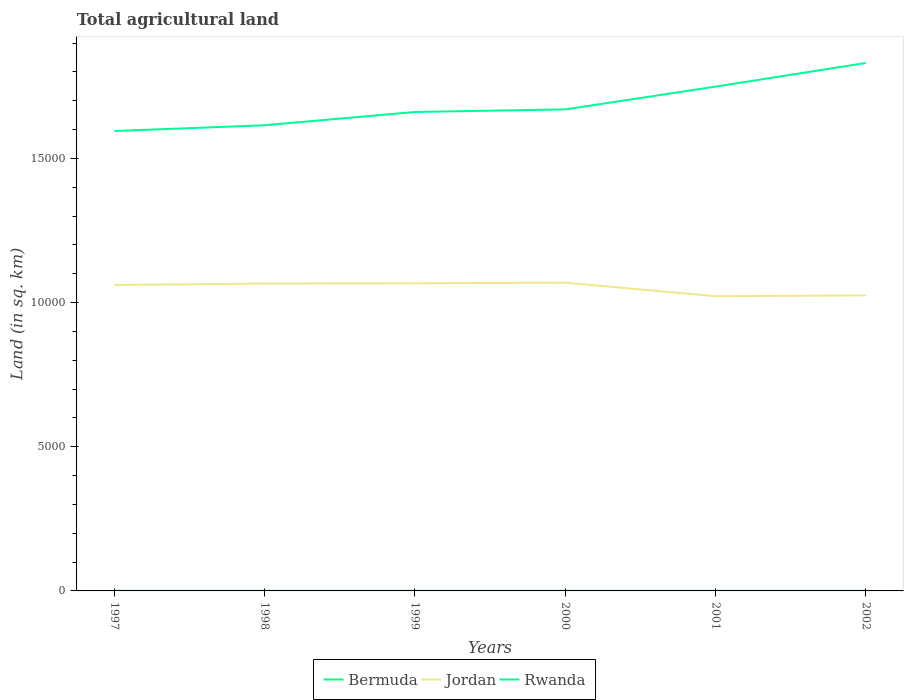How many different coloured lines are there?
Give a very brief answer. 3. Does the line corresponding to Jordan intersect with the line corresponding to Bermuda?
Ensure brevity in your answer.  No. Across all years, what is the maximum total agricultural land in Bermuda?
Give a very brief answer. 4. What is the difference between the highest and the second highest total agricultural land in Rwanda?
Offer a terse response. 2360. How many years are there in the graph?
Your answer should be very brief. 6. What is the difference between two consecutive major ticks on the Y-axis?
Keep it short and to the point. 5000. Does the graph contain grids?
Offer a very short reply. No. Where does the legend appear in the graph?
Your answer should be very brief. Bottom center. How are the legend labels stacked?
Offer a terse response. Horizontal. What is the title of the graph?
Provide a short and direct response. Total agricultural land. What is the label or title of the X-axis?
Offer a terse response. Years. What is the label or title of the Y-axis?
Ensure brevity in your answer.  Land (in sq. km). What is the Land (in sq. km) of Bermuda in 1997?
Keep it short and to the point. 4. What is the Land (in sq. km) of Jordan in 1997?
Your answer should be very brief. 1.06e+04. What is the Land (in sq. km) in Rwanda in 1997?
Make the answer very short. 1.60e+04. What is the Land (in sq. km) of Jordan in 1998?
Offer a terse response. 1.07e+04. What is the Land (in sq. km) in Rwanda in 1998?
Ensure brevity in your answer.  1.62e+04. What is the Land (in sq. km) of Jordan in 1999?
Your response must be concise. 1.07e+04. What is the Land (in sq. km) of Rwanda in 1999?
Your answer should be very brief. 1.66e+04. What is the Land (in sq. km) in Bermuda in 2000?
Provide a succinct answer. 4. What is the Land (in sq. km) of Jordan in 2000?
Keep it short and to the point. 1.07e+04. What is the Land (in sq. km) of Rwanda in 2000?
Your answer should be very brief. 1.67e+04. What is the Land (in sq. km) of Jordan in 2001?
Offer a terse response. 1.02e+04. What is the Land (in sq. km) in Rwanda in 2001?
Your response must be concise. 1.75e+04. What is the Land (in sq. km) of Jordan in 2002?
Keep it short and to the point. 1.02e+04. What is the Land (in sq. km) in Rwanda in 2002?
Keep it short and to the point. 1.83e+04. Across all years, what is the maximum Land (in sq. km) in Jordan?
Provide a succinct answer. 1.07e+04. Across all years, what is the maximum Land (in sq. km) of Rwanda?
Keep it short and to the point. 1.83e+04. Across all years, what is the minimum Land (in sq. km) of Jordan?
Offer a terse response. 1.02e+04. Across all years, what is the minimum Land (in sq. km) in Rwanda?
Your answer should be very brief. 1.60e+04. What is the total Land (in sq. km) of Bermuda in the graph?
Your response must be concise. 24. What is the total Land (in sq. km) of Jordan in the graph?
Give a very brief answer. 6.31e+04. What is the total Land (in sq. km) in Rwanda in the graph?
Your answer should be very brief. 1.01e+05. What is the difference between the Land (in sq. km) of Bermuda in 1997 and that in 1998?
Provide a short and direct response. 0. What is the difference between the Land (in sq. km) in Jordan in 1997 and that in 1998?
Make the answer very short. -50. What is the difference between the Land (in sq. km) of Rwanda in 1997 and that in 1998?
Offer a very short reply. -200. What is the difference between the Land (in sq. km) of Bermuda in 1997 and that in 1999?
Give a very brief answer. 0. What is the difference between the Land (in sq. km) in Jordan in 1997 and that in 1999?
Your answer should be very brief. -60. What is the difference between the Land (in sq. km) in Rwanda in 1997 and that in 1999?
Your answer should be very brief. -660. What is the difference between the Land (in sq. km) in Bermuda in 1997 and that in 2000?
Give a very brief answer. 0. What is the difference between the Land (in sq. km) in Jordan in 1997 and that in 2000?
Keep it short and to the point. -80. What is the difference between the Land (in sq. km) in Rwanda in 1997 and that in 2000?
Keep it short and to the point. -750. What is the difference between the Land (in sq. km) of Bermuda in 1997 and that in 2001?
Ensure brevity in your answer.  0. What is the difference between the Land (in sq. km) of Jordan in 1997 and that in 2001?
Your answer should be compact. 390. What is the difference between the Land (in sq. km) in Rwanda in 1997 and that in 2001?
Make the answer very short. -1540. What is the difference between the Land (in sq. km) in Jordan in 1997 and that in 2002?
Make the answer very short. 360. What is the difference between the Land (in sq. km) in Rwanda in 1997 and that in 2002?
Give a very brief answer. -2360. What is the difference between the Land (in sq. km) of Bermuda in 1998 and that in 1999?
Keep it short and to the point. 0. What is the difference between the Land (in sq. km) in Rwanda in 1998 and that in 1999?
Keep it short and to the point. -460. What is the difference between the Land (in sq. km) of Jordan in 1998 and that in 2000?
Make the answer very short. -30. What is the difference between the Land (in sq. km) of Rwanda in 1998 and that in 2000?
Your response must be concise. -550. What is the difference between the Land (in sq. km) in Bermuda in 1998 and that in 2001?
Offer a terse response. 0. What is the difference between the Land (in sq. km) in Jordan in 1998 and that in 2001?
Your answer should be compact. 440. What is the difference between the Land (in sq. km) in Rwanda in 1998 and that in 2001?
Offer a very short reply. -1340. What is the difference between the Land (in sq. km) in Jordan in 1998 and that in 2002?
Keep it short and to the point. 410. What is the difference between the Land (in sq. km) of Rwanda in 1998 and that in 2002?
Ensure brevity in your answer.  -2160. What is the difference between the Land (in sq. km) in Jordan in 1999 and that in 2000?
Provide a short and direct response. -20. What is the difference between the Land (in sq. km) of Rwanda in 1999 and that in 2000?
Keep it short and to the point. -90. What is the difference between the Land (in sq. km) in Bermuda in 1999 and that in 2001?
Make the answer very short. 0. What is the difference between the Land (in sq. km) in Jordan in 1999 and that in 2001?
Your answer should be very brief. 450. What is the difference between the Land (in sq. km) of Rwanda in 1999 and that in 2001?
Provide a succinct answer. -880. What is the difference between the Land (in sq. km) in Bermuda in 1999 and that in 2002?
Offer a very short reply. 0. What is the difference between the Land (in sq. km) of Jordan in 1999 and that in 2002?
Your answer should be compact. 420. What is the difference between the Land (in sq. km) in Rwanda in 1999 and that in 2002?
Provide a short and direct response. -1700. What is the difference between the Land (in sq. km) of Jordan in 2000 and that in 2001?
Provide a short and direct response. 470. What is the difference between the Land (in sq. km) of Rwanda in 2000 and that in 2001?
Provide a succinct answer. -790. What is the difference between the Land (in sq. km) in Bermuda in 2000 and that in 2002?
Provide a short and direct response. 0. What is the difference between the Land (in sq. km) in Jordan in 2000 and that in 2002?
Make the answer very short. 440. What is the difference between the Land (in sq. km) in Rwanda in 2000 and that in 2002?
Your answer should be very brief. -1610. What is the difference between the Land (in sq. km) of Bermuda in 2001 and that in 2002?
Give a very brief answer. 0. What is the difference between the Land (in sq. km) in Rwanda in 2001 and that in 2002?
Keep it short and to the point. -820. What is the difference between the Land (in sq. km) in Bermuda in 1997 and the Land (in sq. km) in Jordan in 1998?
Your answer should be compact. -1.07e+04. What is the difference between the Land (in sq. km) in Bermuda in 1997 and the Land (in sq. km) in Rwanda in 1998?
Ensure brevity in your answer.  -1.61e+04. What is the difference between the Land (in sq. km) of Jordan in 1997 and the Land (in sq. km) of Rwanda in 1998?
Ensure brevity in your answer.  -5540. What is the difference between the Land (in sq. km) in Bermuda in 1997 and the Land (in sq. km) in Jordan in 1999?
Give a very brief answer. -1.07e+04. What is the difference between the Land (in sq. km) of Bermuda in 1997 and the Land (in sq. km) of Rwanda in 1999?
Ensure brevity in your answer.  -1.66e+04. What is the difference between the Land (in sq. km) of Jordan in 1997 and the Land (in sq. km) of Rwanda in 1999?
Ensure brevity in your answer.  -6000. What is the difference between the Land (in sq. km) in Bermuda in 1997 and the Land (in sq. km) in Jordan in 2000?
Your answer should be very brief. -1.07e+04. What is the difference between the Land (in sq. km) in Bermuda in 1997 and the Land (in sq. km) in Rwanda in 2000?
Make the answer very short. -1.67e+04. What is the difference between the Land (in sq. km) of Jordan in 1997 and the Land (in sq. km) of Rwanda in 2000?
Offer a very short reply. -6090. What is the difference between the Land (in sq. km) of Bermuda in 1997 and the Land (in sq. km) of Jordan in 2001?
Your answer should be very brief. -1.02e+04. What is the difference between the Land (in sq. km) of Bermuda in 1997 and the Land (in sq. km) of Rwanda in 2001?
Your answer should be very brief. -1.75e+04. What is the difference between the Land (in sq. km) in Jordan in 1997 and the Land (in sq. km) in Rwanda in 2001?
Provide a short and direct response. -6880. What is the difference between the Land (in sq. km) in Bermuda in 1997 and the Land (in sq. km) in Jordan in 2002?
Your response must be concise. -1.02e+04. What is the difference between the Land (in sq. km) in Bermuda in 1997 and the Land (in sq. km) in Rwanda in 2002?
Your answer should be compact. -1.83e+04. What is the difference between the Land (in sq. km) of Jordan in 1997 and the Land (in sq. km) of Rwanda in 2002?
Ensure brevity in your answer.  -7700. What is the difference between the Land (in sq. km) of Bermuda in 1998 and the Land (in sq. km) of Jordan in 1999?
Give a very brief answer. -1.07e+04. What is the difference between the Land (in sq. km) in Bermuda in 1998 and the Land (in sq. km) in Rwanda in 1999?
Offer a very short reply. -1.66e+04. What is the difference between the Land (in sq. km) of Jordan in 1998 and the Land (in sq. km) of Rwanda in 1999?
Provide a short and direct response. -5950. What is the difference between the Land (in sq. km) of Bermuda in 1998 and the Land (in sq. km) of Jordan in 2000?
Give a very brief answer. -1.07e+04. What is the difference between the Land (in sq. km) of Bermuda in 1998 and the Land (in sq. km) of Rwanda in 2000?
Provide a short and direct response. -1.67e+04. What is the difference between the Land (in sq. km) in Jordan in 1998 and the Land (in sq. km) in Rwanda in 2000?
Offer a very short reply. -6040. What is the difference between the Land (in sq. km) in Bermuda in 1998 and the Land (in sq. km) in Jordan in 2001?
Provide a succinct answer. -1.02e+04. What is the difference between the Land (in sq. km) of Bermuda in 1998 and the Land (in sq. km) of Rwanda in 2001?
Make the answer very short. -1.75e+04. What is the difference between the Land (in sq. km) of Jordan in 1998 and the Land (in sq. km) of Rwanda in 2001?
Provide a short and direct response. -6830. What is the difference between the Land (in sq. km) of Bermuda in 1998 and the Land (in sq. km) of Jordan in 2002?
Keep it short and to the point. -1.02e+04. What is the difference between the Land (in sq. km) of Bermuda in 1998 and the Land (in sq. km) of Rwanda in 2002?
Give a very brief answer. -1.83e+04. What is the difference between the Land (in sq. km) in Jordan in 1998 and the Land (in sq. km) in Rwanda in 2002?
Offer a terse response. -7650. What is the difference between the Land (in sq. km) of Bermuda in 1999 and the Land (in sq. km) of Jordan in 2000?
Give a very brief answer. -1.07e+04. What is the difference between the Land (in sq. km) of Bermuda in 1999 and the Land (in sq. km) of Rwanda in 2000?
Provide a succinct answer. -1.67e+04. What is the difference between the Land (in sq. km) of Jordan in 1999 and the Land (in sq. km) of Rwanda in 2000?
Offer a very short reply. -6030. What is the difference between the Land (in sq. km) in Bermuda in 1999 and the Land (in sq. km) in Jordan in 2001?
Your answer should be compact. -1.02e+04. What is the difference between the Land (in sq. km) of Bermuda in 1999 and the Land (in sq. km) of Rwanda in 2001?
Your answer should be very brief. -1.75e+04. What is the difference between the Land (in sq. km) of Jordan in 1999 and the Land (in sq. km) of Rwanda in 2001?
Provide a succinct answer. -6820. What is the difference between the Land (in sq. km) of Bermuda in 1999 and the Land (in sq. km) of Jordan in 2002?
Ensure brevity in your answer.  -1.02e+04. What is the difference between the Land (in sq. km) in Bermuda in 1999 and the Land (in sq. km) in Rwanda in 2002?
Offer a terse response. -1.83e+04. What is the difference between the Land (in sq. km) of Jordan in 1999 and the Land (in sq. km) of Rwanda in 2002?
Offer a very short reply. -7640. What is the difference between the Land (in sq. km) in Bermuda in 2000 and the Land (in sq. km) in Jordan in 2001?
Give a very brief answer. -1.02e+04. What is the difference between the Land (in sq. km) of Bermuda in 2000 and the Land (in sq. km) of Rwanda in 2001?
Offer a very short reply. -1.75e+04. What is the difference between the Land (in sq. km) of Jordan in 2000 and the Land (in sq. km) of Rwanda in 2001?
Provide a short and direct response. -6800. What is the difference between the Land (in sq. km) in Bermuda in 2000 and the Land (in sq. km) in Jordan in 2002?
Make the answer very short. -1.02e+04. What is the difference between the Land (in sq. km) of Bermuda in 2000 and the Land (in sq. km) of Rwanda in 2002?
Offer a very short reply. -1.83e+04. What is the difference between the Land (in sq. km) of Jordan in 2000 and the Land (in sq. km) of Rwanda in 2002?
Your answer should be very brief. -7620. What is the difference between the Land (in sq. km) of Bermuda in 2001 and the Land (in sq. km) of Jordan in 2002?
Offer a very short reply. -1.02e+04. What is the difference between the Land (in sq. km) of Bermuda in 2001 and the Land (in sq. km) of Rwanda in 2002?
Your response must be concise. -1.83e+04. What is the difference between the Land (in sq. km) in Jordan in 2001 and the Land (in sq. km) in Rwanda in 2002?
Ensure brevity in your answer.  -8090. What is the average Land (in sq. km) in Bermuda per year?
Offer a very short reply. 4. What is the average Land (in sq. km) in Jordan per year?
Keep it short and to the point. 1.05e+04. What is the average Land (in sq. km) of Rwanda per year?
Offer a very short reply. 1.69e+04. In the year 1997, what is the difference between the Land (in sq. km) in Bermuda and Land (in sq. km) in Jordan?
Provide a succinct answer. -1.06e+04. In the year 1997, what is the difference between the Land (in sq. km) of Bermuda and Land (in sq. km) of Rwanda?
Provide a short and direct response. -1.59e+04. In the year 1997, what is the difference between the Land (in sq. km) in Jordan and Land (in sq. km) in Rwanda?
Ensure brevity in your answer.  -5340. In the year 1998, what is the difference between the Land (in sq. km) in Bermuda and Land (in sq. km) in Jordan?
Your response must be concise. -1.07e+04. In the year 1998, what is the difference between the Land (in sq. km) in Bermuda and Land (in sq. km) in Rwanda?
Offer a terse response. -1.61e+04. In the year 1998, what is the difference between the Land (in sq. km) in Jordan and Land (in sq. km) in Rwanda?
Keep it short and to the point. -5490. In the year 1999, what is the difference between the Land (in sq. km) of Bermuda and Land (in sq. km) of Jordan?
Provide a succinct answer. -1.07e+04. In the year 1999, what is the difference between the Land (in sq. km) in Bermuda and Land (in sq. km) in Rwanda?
Give a very brief answer. -1.66e+04. In the year 1999, what is the difference between the Land (in sq. km) in Jordan and Land (in sq. km) in Rwanda?
Provide a short and direct response. -5940. In the year 2000, what is the difference between the Land (in sq. km) in Bermuda and Land (in sq. km) in Jordan?
Make the answer very short. -1.07e+04. In the year 2000, what is the difference between the Land (in sq. km) of Bermuda and Land (in sq. km) of Rwanda?
Provide a short and direct response. -1.67e+04. In the year 2000, what is the difference between the Land (in sq. km) in Jordan and Land (in sq. km) in Rwanda?
Keep it short and to the point. -6010. In the year 2001, what is the difference between the Land (in sq. km) in Bermuda and Land (in sq. km) in Jordan?
Give a very brief answer. -1.02e+04. In the year 2001, what is the difference between the Land (in sq. km) of Bermuda and Land (in sq. km) of Rwanda?
Keep it short and to the point. -1.75e+04. In the year 2001, what is the difference between the Land (in sq. km) in Jordan and Land (in sq. km) in Rwanda?
Provide a short and direct response. -7270. In the year 2002, what is the difference between the Land (in sq. km) in Bermuda and Land (in sq. km) in Jordan?
Provide a short and direct response. -1.02e+04. In the year 2002, what is the difference between the Land (in sq. km) of Bermuda and Land (in sq. km) of Rwanda?
Ensure brevity in your answer.  -1.83e+04. In the year 2002, what is the difference between the Land (in sq. km) of Jordan and Land (in sq. km) of Rwanda?
Offer a very short reply. -8060. What is the ratio of the Land (in sq. km) of Jordan in 1997 to that in 1998?
Offer a terse response. 1. What is the ratio of the Land (in sq. km) of Rwanda in 1997 to that in 1998?
Your response must be concise. 0.99. What is the ratio of the Land (in sq. km) in Rwanda in 1997 to that in 1999?
Your answer should be very brief. 0.96. What is the ratio of the Land (in sq. km) in Rwanda in 1997 to that in 2000?
Provide a short and direct response. 0.96. What is the ratio of the Land (in sq. km) of Jordan in 1997 to that in 2001?
Make the answer very short. 1.04. What is the ratio of the Land (in sq. km) of Rwanda in 1997 to that in 2001?
Provide a succinct answer. 0.91. What is the ratio of the Land (in sq. km) in Bermuda in 1997 to that in 2002?
Offer a very short reply. 1. What is the ratio of the Land (in sq. km) in Jordan in 1997 to that in 2002?
Your response must be concise. 1.04. What is the ratio of the Land (in sq. km) in Rwanda in 1997 to that in 2002?
Your response must be concise. 0.87. What is the ratio of the Land (in sq. km) of Bermuda in 1998 to that in 1999?
Ensure brevity in your answer.  1. What is the ratio of the Land (in sq. km) of Rwanda in 1998 to that in 1999?
Provide a succinct answer. 0.97. What is the ratio of the Land (in sq. km) in Rwanda in 1998 to that in 2000?
Ensure brevity in your answer.  0.97. What is the ratio of the Land (in sq. km) of Bermuda in 1998 to that in 2001?
Give a very brief answer. 1. What is the ratio of the Land (in sq. km) in Jordan in 1998 to that in 2001?
Offer a very short reply. 1.04. What is the ratio of the Land (in sq. km) in Rwanda in 1998 to that in 2001?
Provide a succinct answer. 0.92. What is the ratio of the Land (in sq. km) of Bermuda in 1998 to that in 2002?
Your answer should be compact. 1. What is the ratio of the Land (in sq. km) in Rwanda in 1998 to that in 2002?
Provide a short and direct response. 0.88. What is the ratio of the Land (in sq. km) of Jordan in 1999 to that in 2000?
Your response must be concise. 1. What is the ratio of the Land (in sq. km) of Rwanda in 1999 to that in 2000?
Provide a succinct answer. 0.99. What is the ratio of the Land (in sq. km) of Jordan in 1999 to that in 2001?
Your answer should be compact. 1.04. What is the ratio of the Land (in sq. km) of Rwanda in 1999 to that in 2001?
Offer a terse response. 0.95. What is the ratio of the Land (in sq. km) in Bermuda in 1999 to that in 2002?
Your answer should be compact. 1. What is the ratio of the Land (in sq. km) of Jordan in 1999 to that in 2002?
Provide a short and direct response. 1.04. What is the ratio of the Land (in sq. km) in Rwanda in 1999 to that in 2002?
Your response must be concise. 0.91. What is the ratio of the Land (in sq. km) of Bermuda in 2000 to that in 2001?
Provide a short and direct response. 1. What is the ratio of the Land (in sq. km) in Jordan in 2000 to that in 2001?
Keep it short and to the point. 1.05. What is the ratio of the Land (in sq. km) in Rwanda in 2000 to that in 2001?
Provide a succinct answer. 0.95. What is the ratio of the Land (in sq. km) in Bermuda in 2000 to that in 2002?
Give a very brief answer. 1. What is the ratio of the Land (in sq. km) of Jordan in 2000 to that in 2002?
Ensure brevity in your answer.  1.04. What is the ratio of the Land (in sq. km) in Rwanda in 2000 to that in 2002?
Your answer should be compact. 0.91. What is the ratio of the Land (in sq. km) of Bermuda in 2001 to that in 2002?
Give a very brief answer. 1. What is the ratio of the Land (in sq. km) in Rwanda in 2001 to that in 2002?
Your response must be concise. 0.96. What is the difference between the highest and the second highest Land (in sq. km) in Jordan?
Offer a very short reply. 20. What is the difference between the highest and the second highest Land (in sq. km) of Rwanda?
Provide a succinct answer. 820. What is the difference between the highest and the lowest Land (in sq. km) of Jordan?
Provide a succinct answer. 470. What is the difference between the highest and the lowest Land (in sq. km) of Rwanda?
Provide a succinct answer. 2360. 